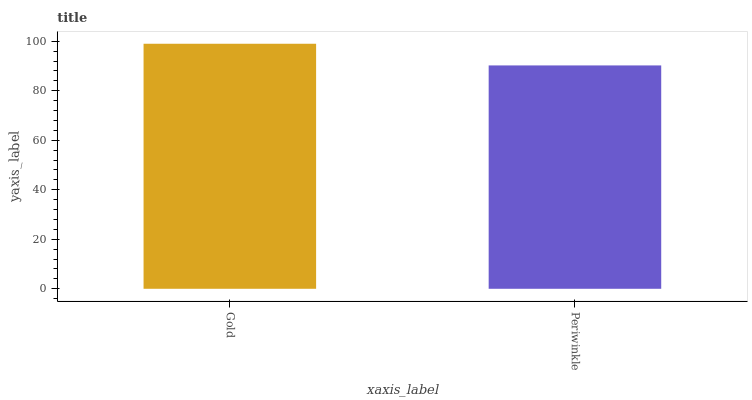Is Periwinkle the minimum?
Answer yes or no. Yes. Is Gold the maximum?
Answer yes or no. Yes. Is Periwinkle the maximum?
Answer yes or no. No. Is Gold greater than Periwinkle?
Answer yes or no. Yes. Is Periwinkle less than Gold?
Answer yes or no. Yes. Is Periwinkle greater than Gold?
Answer yes or no. No. Is Gold less than Periwinkle?
Answer yes or no. No. Is Gold the high median?
Answer yes or no. Yes. Is Periwinkle the low median?
Answer yes or no. Yes. Is Periwinkle the high median?
Answer yes or no. No. Is Gold the low median?
Answer yes or no. No. 